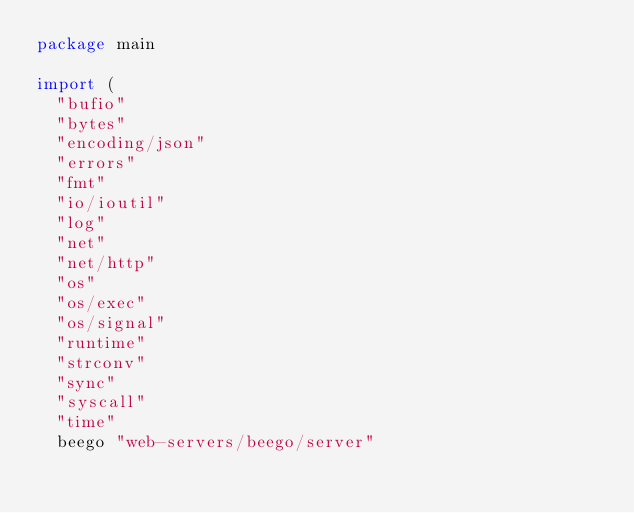Convert code to text. <code><loc_0><loc_0><loc_500><loc_500><_Go_>package main

import (
	"bufio"
	"bytes"
	"encoding/json"
	"errors"
	"fmt"
	"io/ioutil"
	"log"
	"net"
	"net/http"
	"os"
	"os/exec"
	"os/signal"
	"runtime"
	"strconv"
	"sync"
	"syscall"
	"time"
	beego "web-servers/beego/server"</code> 